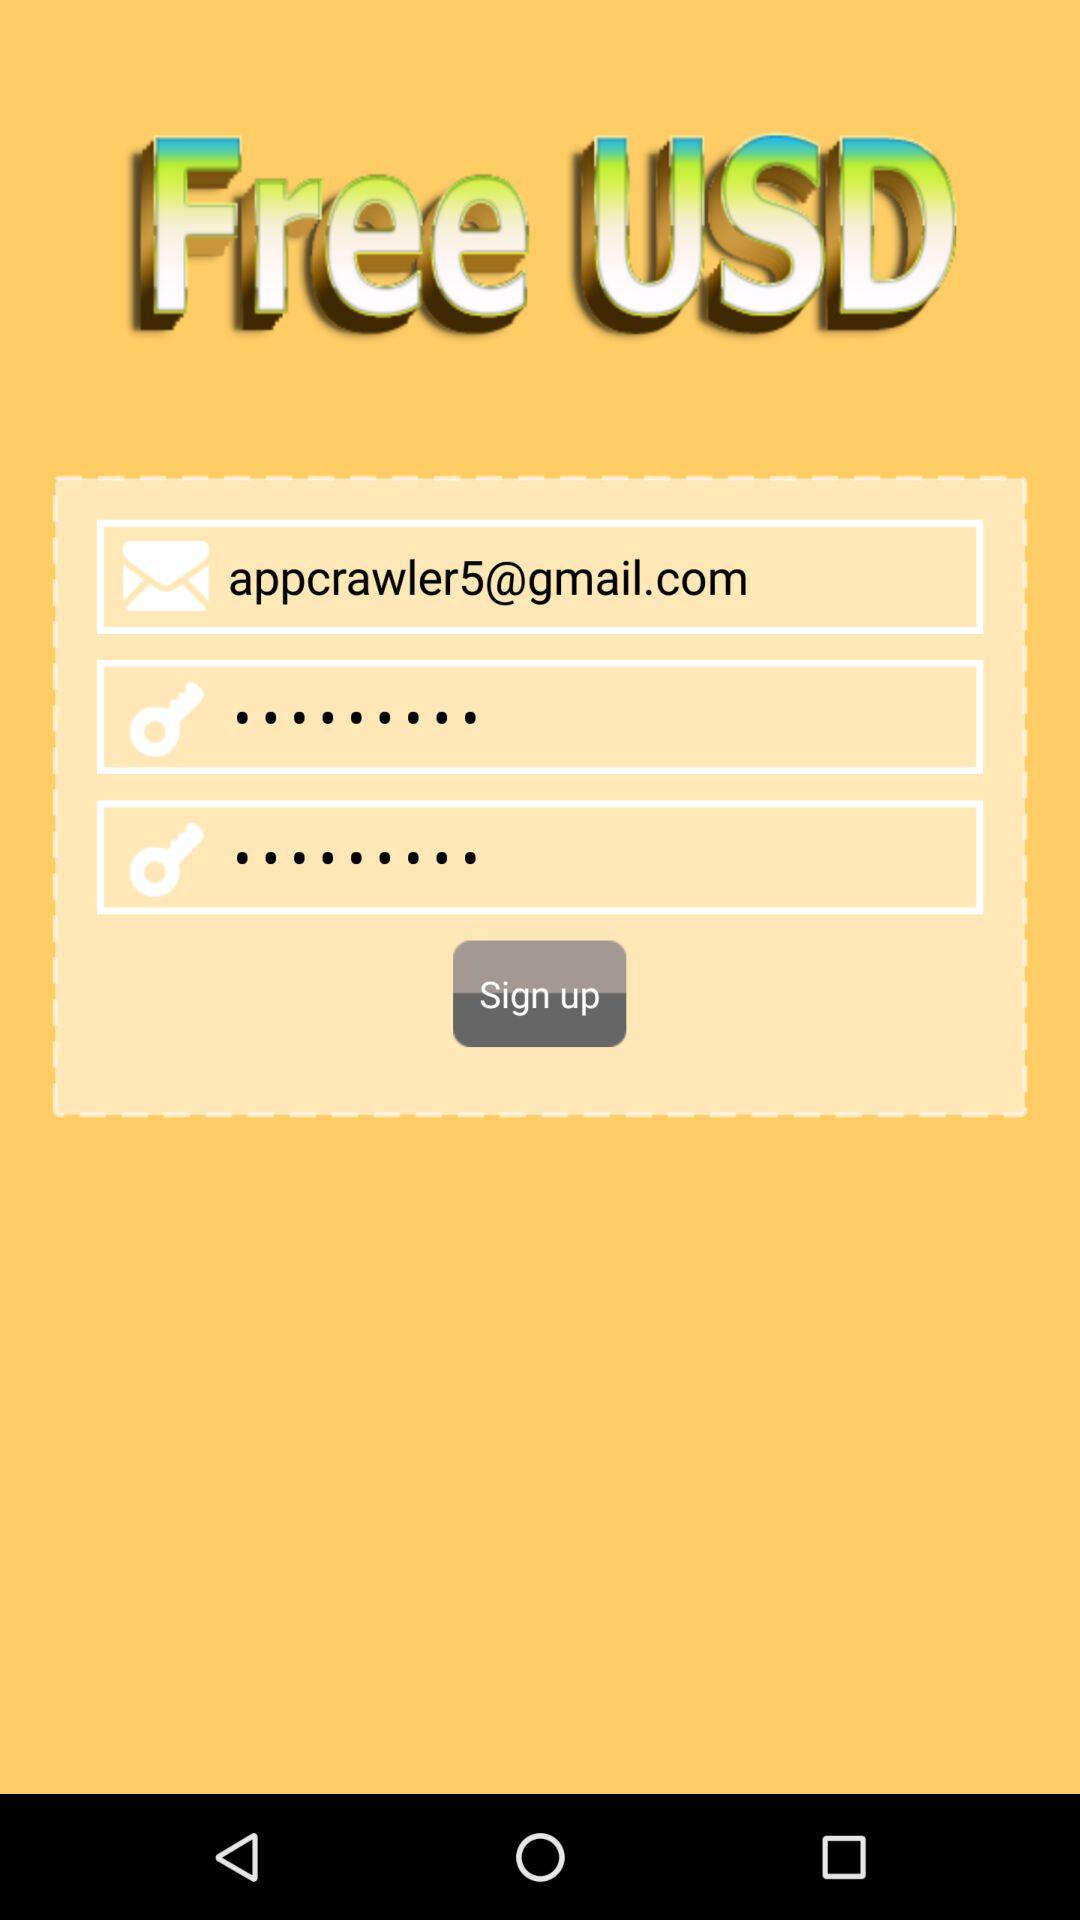What is the name of the user?
When the provided information is insufficient, respond with <no answer>. <no answer> 